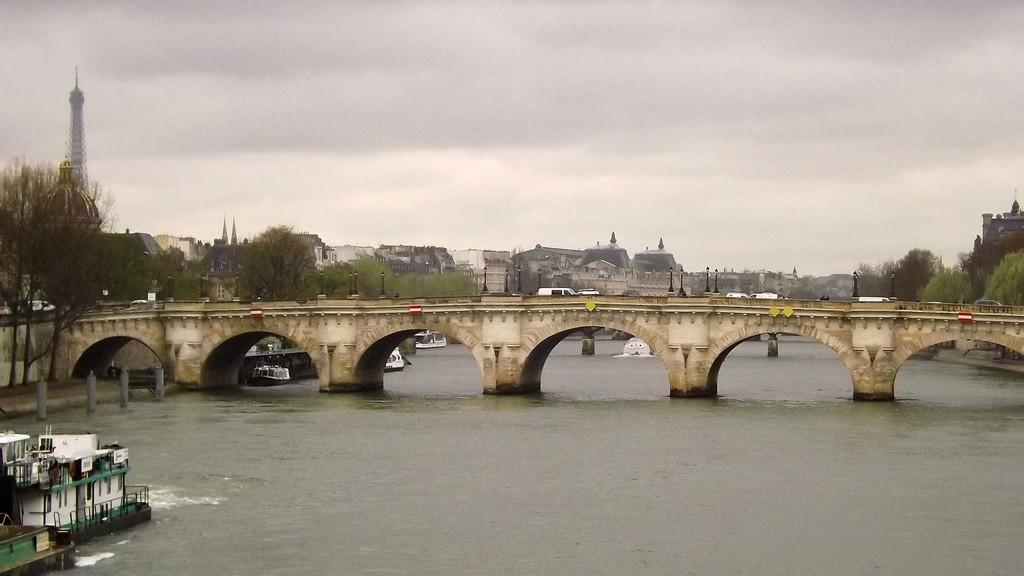What natural feature is present in the image? There is a river in the image. What structure is built over the river? There is a long tunnel bridge over the river. What type of buildings can be seen in the background of the image? There are houses in the background of the image. What type of vegetation is present in the background of the image? There are trees in the background of the image. How would you describe the weather or mood of the image based on the sky? The sky appears gloomy in the image. What type of protest is happening near the river in the image? There is no protest present in the image; it only features a river, a long tunnel bridge, houses, trees, and a gloomy sky. What kind of experience can be gained from the volcano in the image? There is no volcano present in the image; it only features a river, a long tunnel bridge, houses, trees, and a gloomy sky. 